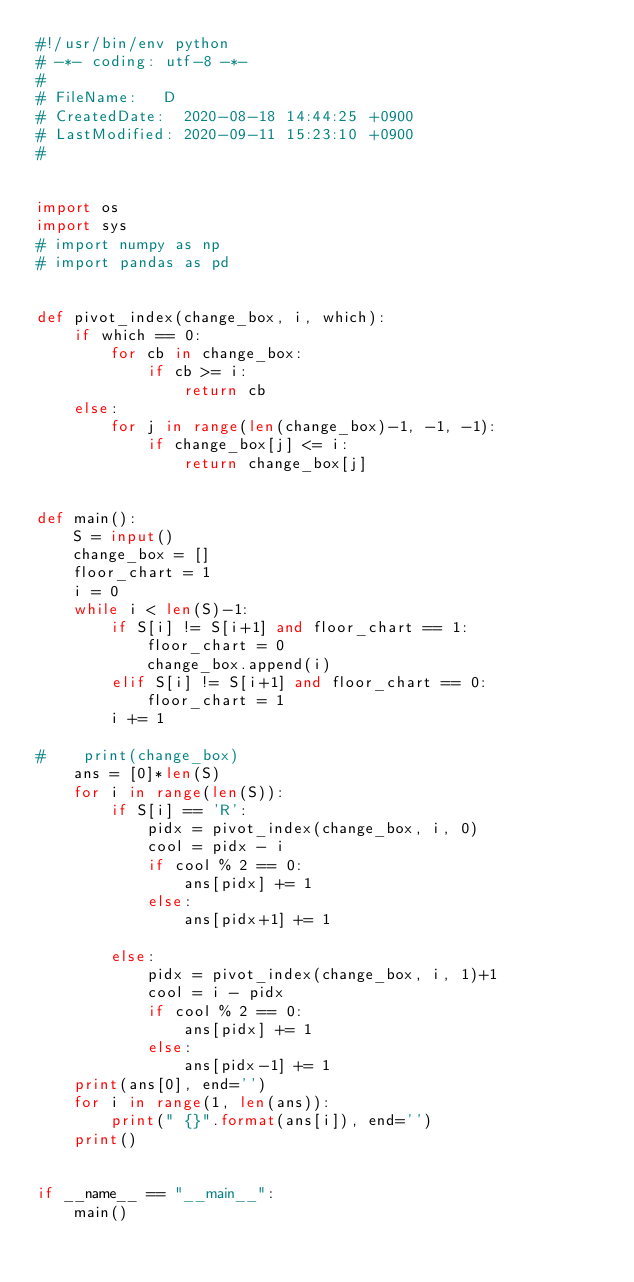<code> <loc_0><loc_0><loc_500><loc_500><_Python_>#!/usr/bin/env python
# -*- coding: utf-8 -*-
#
# FileName: 	D
# CreatedDate:  2020-08-18 14:44:25 +0900
# LastModified: 2020-09-11 15:23:10 +0900
#


import os
import sys
# import numpy as np
# import pandas as pd


def pivot_index(change_box, i, which):
    if which == 0:
        for cb in change_box:
            if cb >= i:
                return cb
    else:
        for j in range(len(change_box)-1, -1, -1):
            if change_box[j] <= i:
                return change_box[j]


def main():
    S = input()
    change_box = []
    floor_chart = 1
    i = 0
    while i < len(S)-1:
        if S[i] != S[i+1] and floor_chart == 1:
            floor_chart = 0
            change_box.append(i)
        elif S[i] != S[i+1] and floor_chart == 0:
            floor_chart = 1
        i += 1

#    print(change_box)
    ans = [0]*len(S)
    for i in range(len(S)):
        if S[i] == 'R':
            pidx = pivot_index(change_box, i, 0)
            cool = pidx - i
            if cool % 2 == 0:
                ans[pidx] += 1
            else:
                ans[pidx+1] += 1

        else:
            pidx = pivot_index(change_box, i, 1)+1
            cool = i - pidx
            if cool % 2 == 0:
                ans[pidx] += 1
            else:
                ans[pidx-1] += 1
    print(ans[0], end='')
    for i in range(1, len(ans)):
        print(" {}".format(ans[i]), end='')
    print()


if __name__ == "__main__":
    main()
</code> 